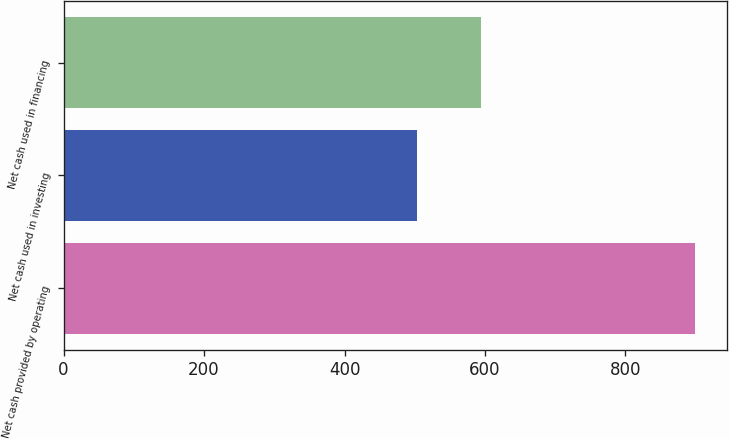Convert chart to OTSL. <chart><loc_0><loc_0><loc_500><loc_500><bar_chart><fcel>Net cash provided by operating<fcel>Net cash used in investing<fcel>Net cash used in financing<nl><fcel>899.5<fcel>503.4<fcel>593.7<nl></chart> 